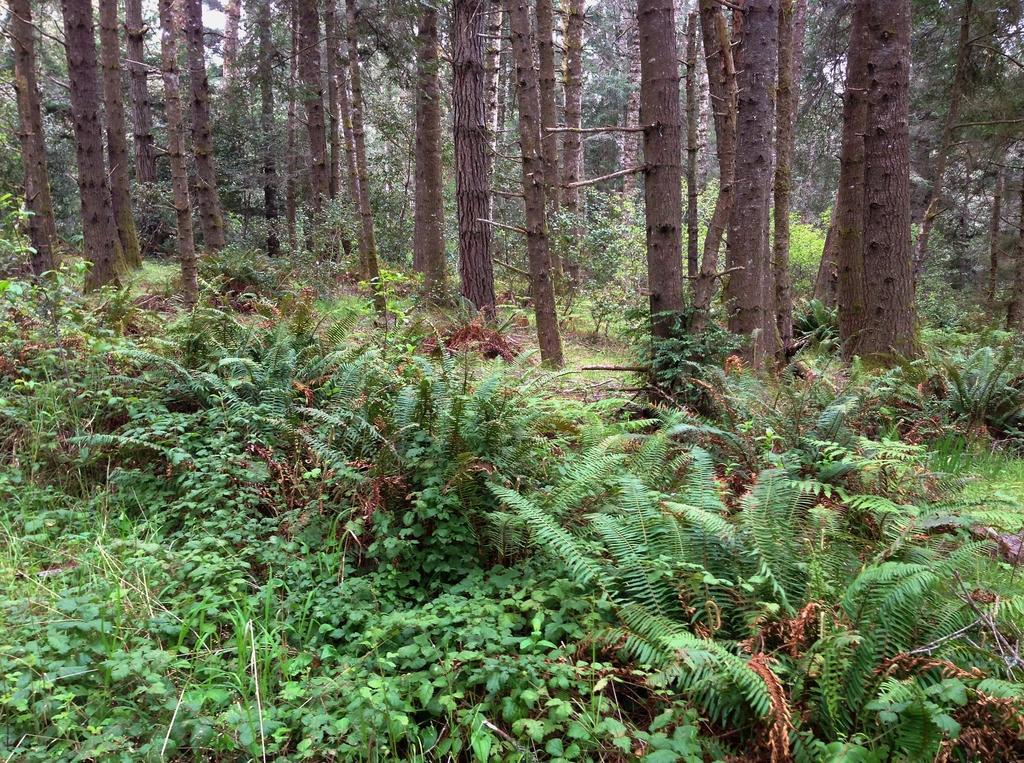Can you describe this image briefly? In this image at the bottom there are some plants and grass, in the center there are some trees. 